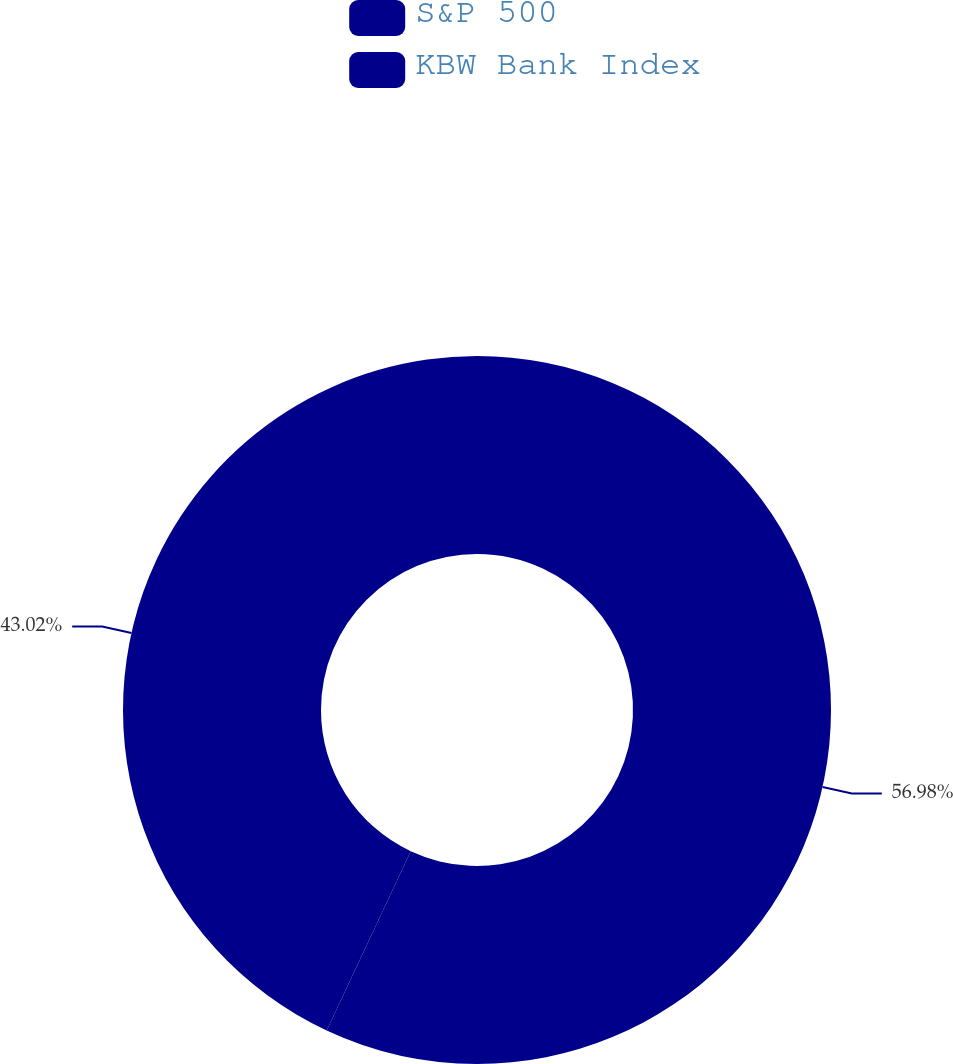Convert chart to OTSL. <chart><loc_0><loc_0><loc_500><loc_500><pie_chart><fcel>S&P 500<fcel>KBW Bank Index<nl><fcel>56.98%<fcel>43.02%<nl></chart> 